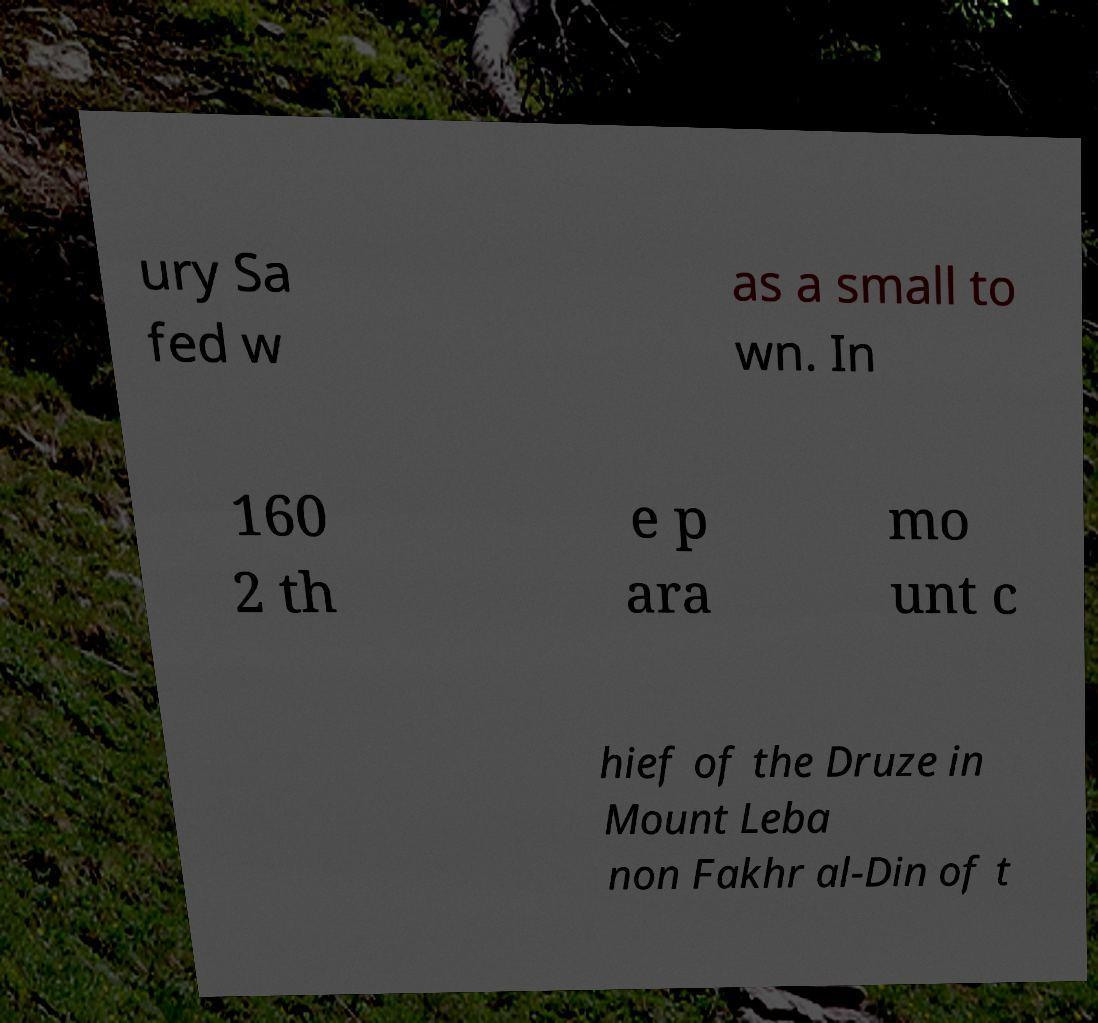Can you accurately transcribe the text from the provided image for me? ury Sa fed w as a small to wn. In 160 2 th e p ara mo unt c hief of the Druze in Mount Leba non Fakhr al-Din of t 